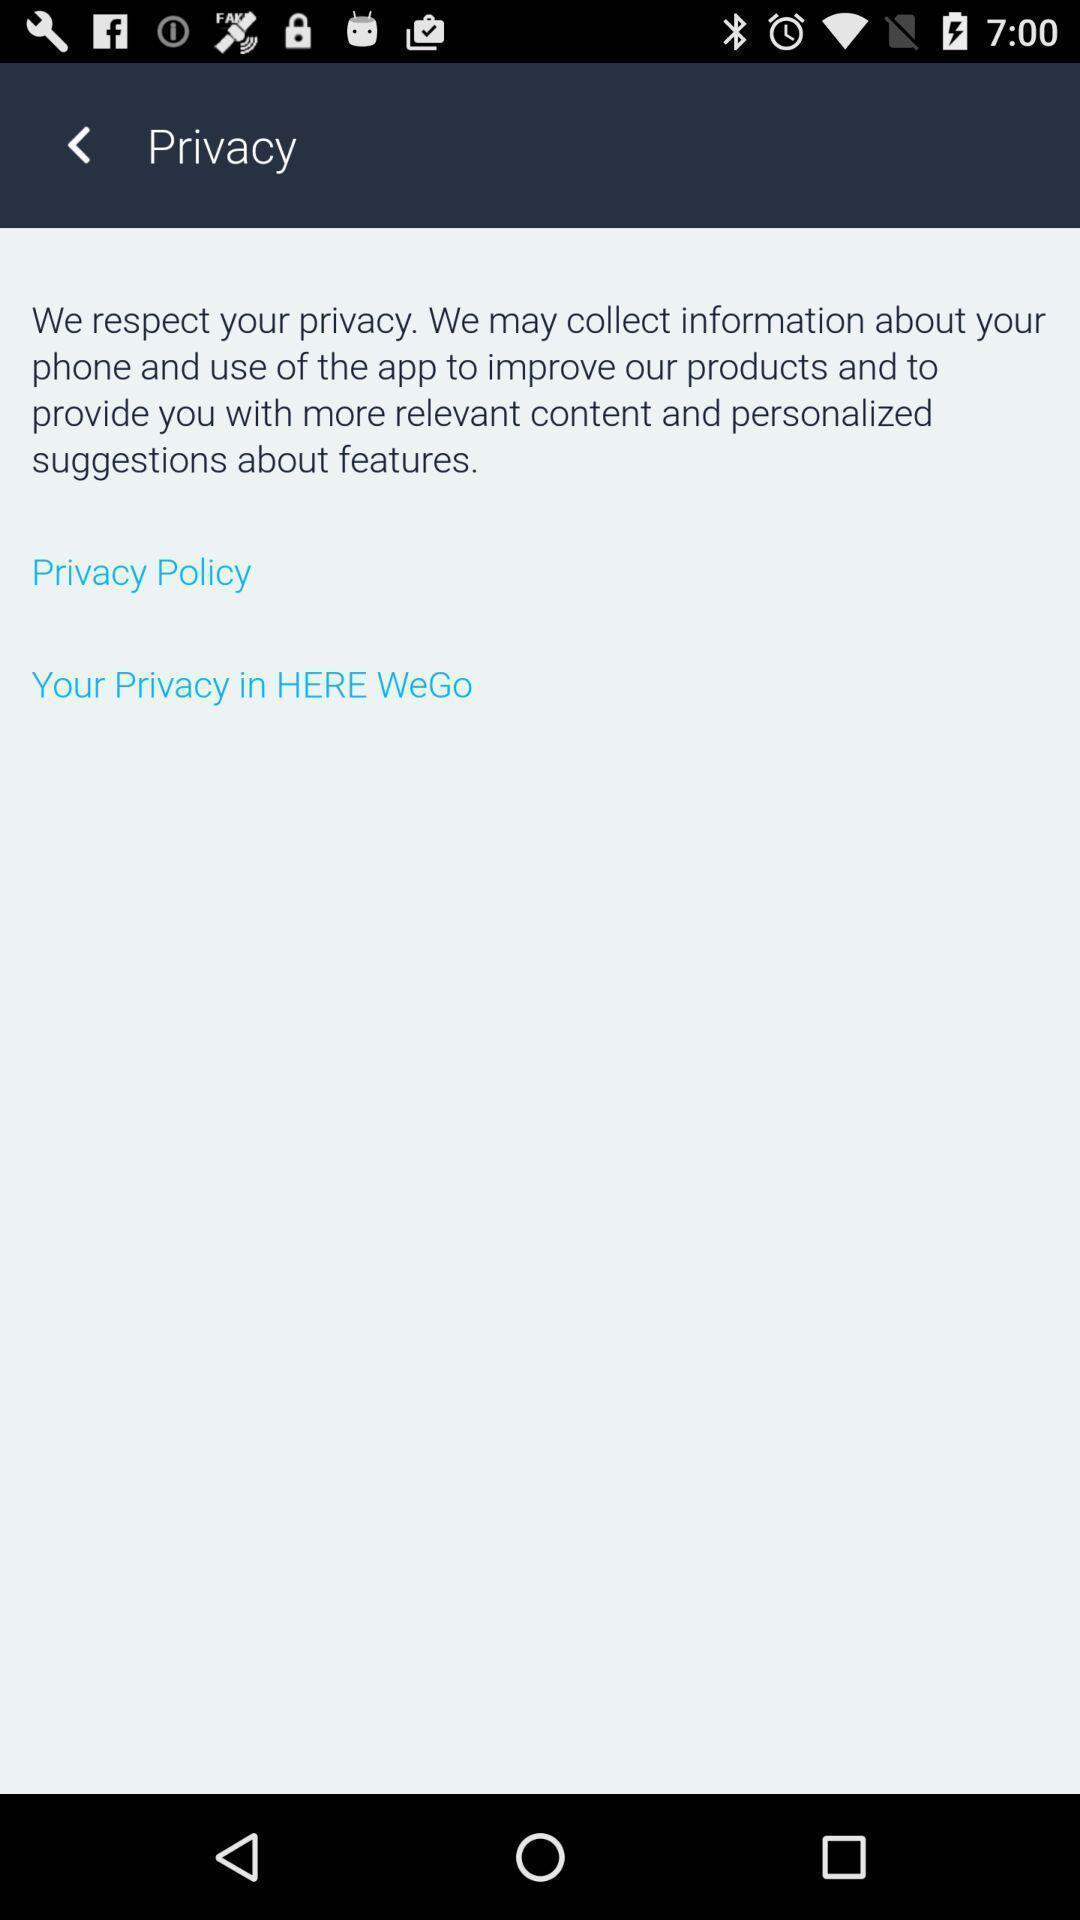Please provide a description for this image. Privacy page displaying a message. 